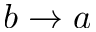<formula> <loc_0><loc_0><loc_500><loc_500>b \to a</formula> 